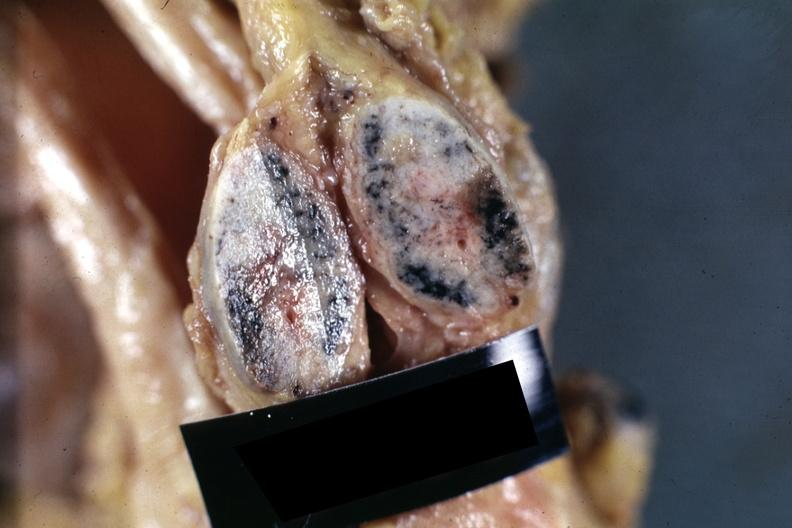what is present?
Answer the question using a single word or phrase. Lymph node 